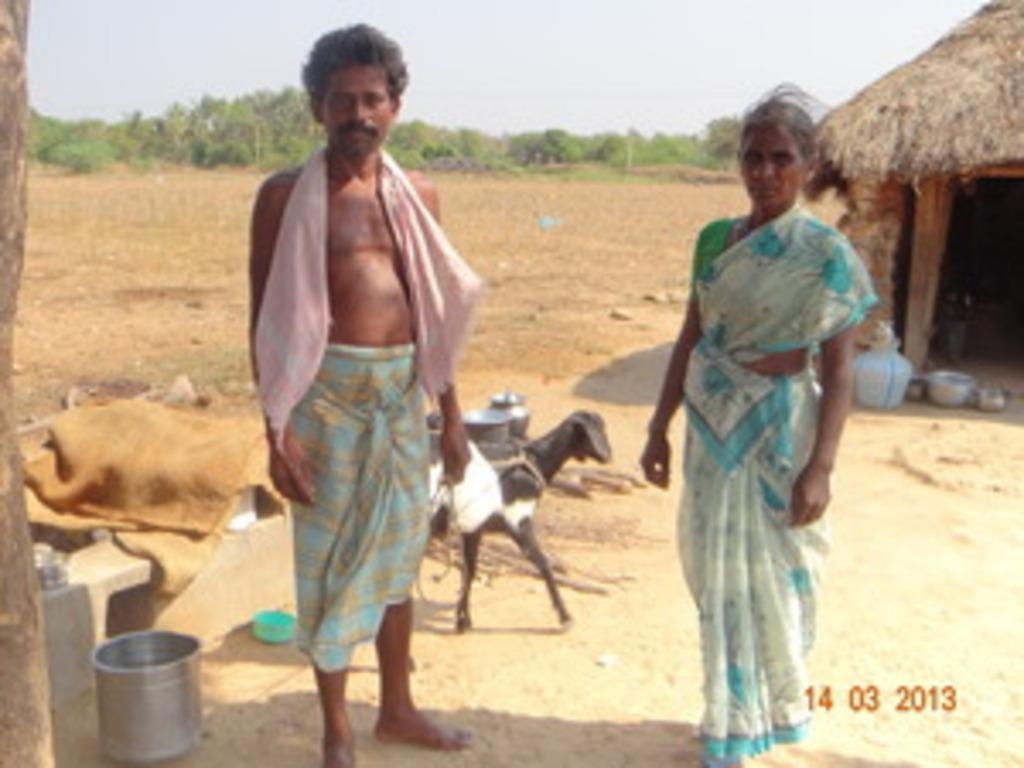How many people are in the foreground of the image? There are two people standing in the foreground of the image. What is located behind the people? There is a goat behind the people. What objects can be seen in the image besides the people and the goat? Vessels are present in the image. What type of structure is visible in the image? There is a hut in the image. What can be seen in the background of the image? Trees are present in the background of the image. What type of terrain is visible in the image? There is empty land visible in the image. What type of berry is being used to make jam in the image? There is no berry or jam present in the image. 